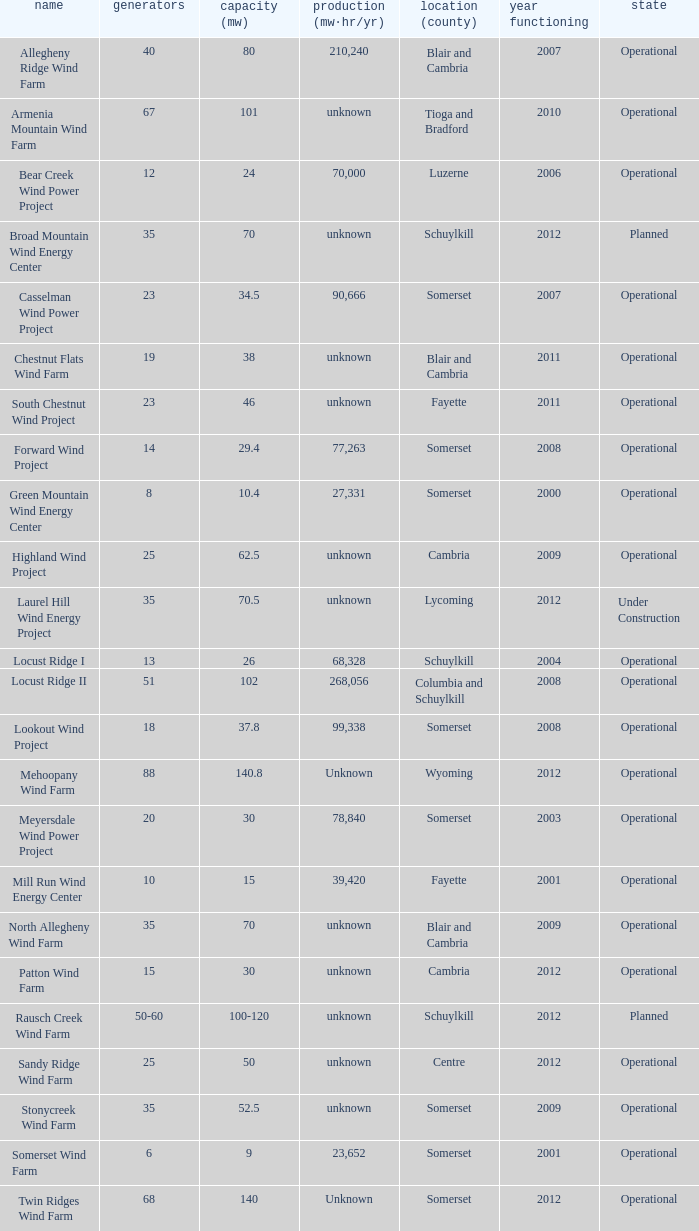What farm has a capacity of 70 and is operational? North Allegheny Wind Farm. 